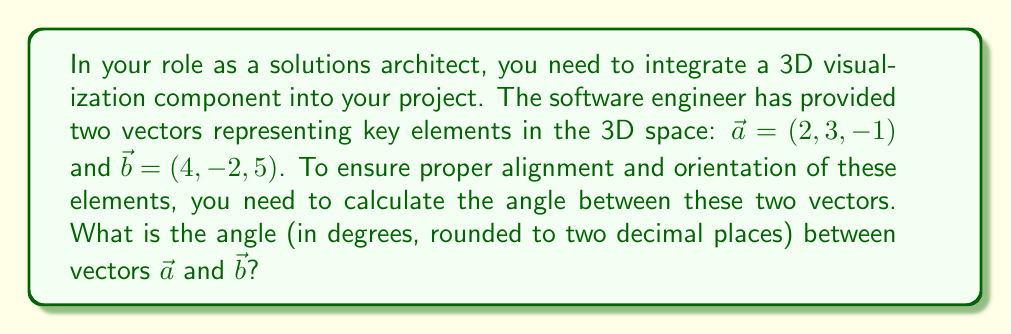Can you solve this math problem? To find the angle between two vectors in 3D space, we can use the dot product formula:

$$\cos \theta = \frac{\vec{a} \cdot \vec{b}}{|\vec{a}| |\vec{b}|}$$

Where $\theta$ is the angle between the vectors, $\vec{a} \cdot \vec{b}$ is the dot product, and $|\vec{a}|$ and $|\vec{b}|$ are the magnitudes of the vectors.

Step 1: Calculate the dot product $\vec{a} \cdot \vec{b}$
$$\vec{a} \cdot \vec{b} = (2 \times 4) + (3 \times -2) + (-1 \times 5) = 8 - 6 - 5 = -3$$

Step 2: Calculate the magnitudes of $\vec{a}$ and $\vec{b}$
$$|\vec{a}| = \sqrt{2^2 + 3^2 + (-1)^2} = \sqrt{4 + 9 + 1} = \sqrt{14}$$
$$|\vec{b}| = \sqrt{4^2 + (-2)^2 + 5^2} = \sqrt{16 + 4 + 25} = \sqrt{45}$$

Step 3: Apply the dot product formula
$$\cos \theta = \frac{-3}{\sqrt{14} \sqrt{45}}$$

Step 4: Calculate $\theta$ using the inverse cosine (arccos) function
$$\theta = \arccos\left(\frac{-3}{\sqrt{14} \sqrt{45}}\right)$$

Step 5: Convert radians to degrees and round to two decimal places
$$\theta \approx 97.18\text{°}$$
Answer: 97.18° 